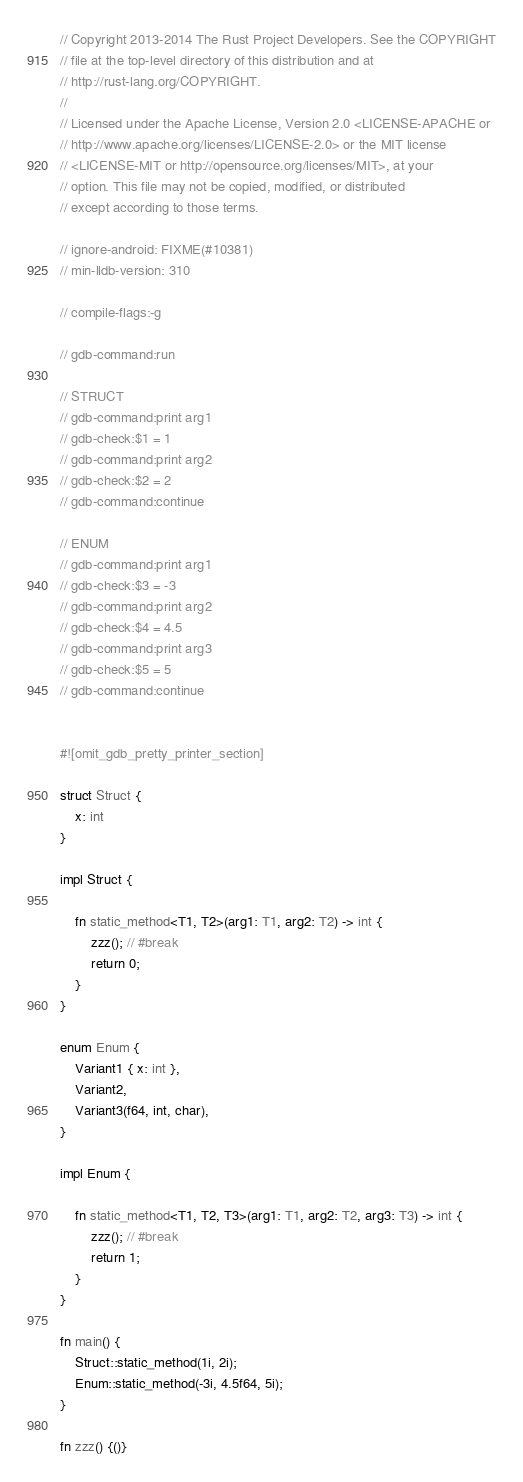<code> <loc_0><loc_0><loc_500><loc_500><_Rust_>// Copyright 2013-2014 The Rust Project Developers. See the COPYRIGHT
// file at the top-level directory of this distribution and at
// http://rust-lang.org/COPYRIGHT.
//
// Licensed under the Apache License, Version 2.0 <LICENSE-APACHE or
// http://www.apache.org/licenses/LICENSE-2.0> or the MIT license
// <LICENSE-MIT or http://opensource.org/licenses/MIT>, at your
// option. This file may not be copied, modified, or distributed
// except according to those terms.

// ignore-android: FIXME(#10381)
// min-lldb-version: 310

// compile-flags:-g

// gdb-command:run

// STRUCT
// gdb-command:print arg1
// gdb-check:$1 = 1
// gdb-command:print arg2
// gdb-check:$2 = 2
// gdb-command:continue

// ENUM
// gdb-command:print arg1
// gdb-check:$3 = -3
// gdb-command:print arg2
// gdb-check:$4 = 4.5
// gdb-command:print arg3
// gdb-check:$5 = 5
// gdb-command:continue


#![omit_gdb_pretty_printer_section]

struct Struct {
    x: int
}

impl Struct {

    fn static_method<T1, T2>(arg1: T1, arg2: T2) -> int {
        zzz(); // #break
        return 0;
    }
}

enum Enum {
    Variant1 { x: int },
    Variant2,
    Variant3(f64, int, char),
}

impl Enum {

    fn static_method<T1, T2, T3>(arg1: T1, arg2: T2, arg3: T3) -> int {
        zzz(); // #break
        return 1;
    }
}

fn main() {
    Struct::static_method(1i, 2i);
    Enum::static_method(-3i, 4.5f64, 5i);
}

fn zzz() {()}
</code> 